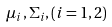Convert formula to latex. <formula><loc_0><loc_0><loc_500><loc_500>\mu _ { i } , \Sigma _ { i } , ( i = 1 , 2 )</formula> 